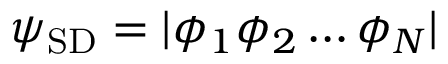Convert formula to latex. <formula><loc_0><loc_0><loc_500><loc_500>\psi _ { S D } = | \phi _ { 1 } \phi _ { 2 } \dots \phi _ { N } |</formula> 